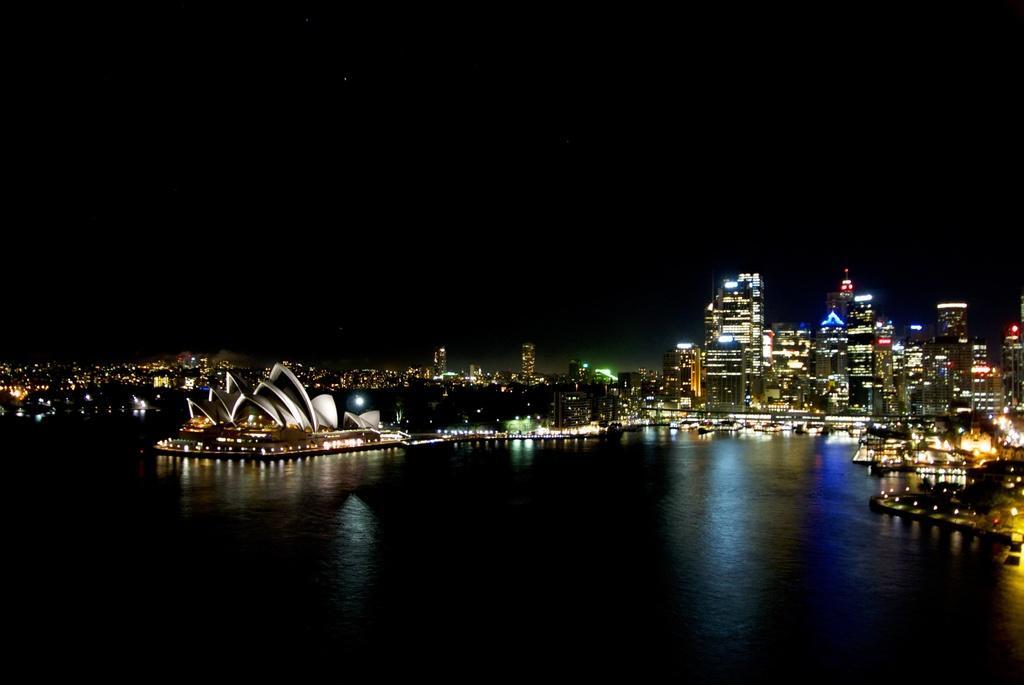Please provide a concise description of this image. In this image there is a water surface, in the background there is an architecture, buildings and lights. 